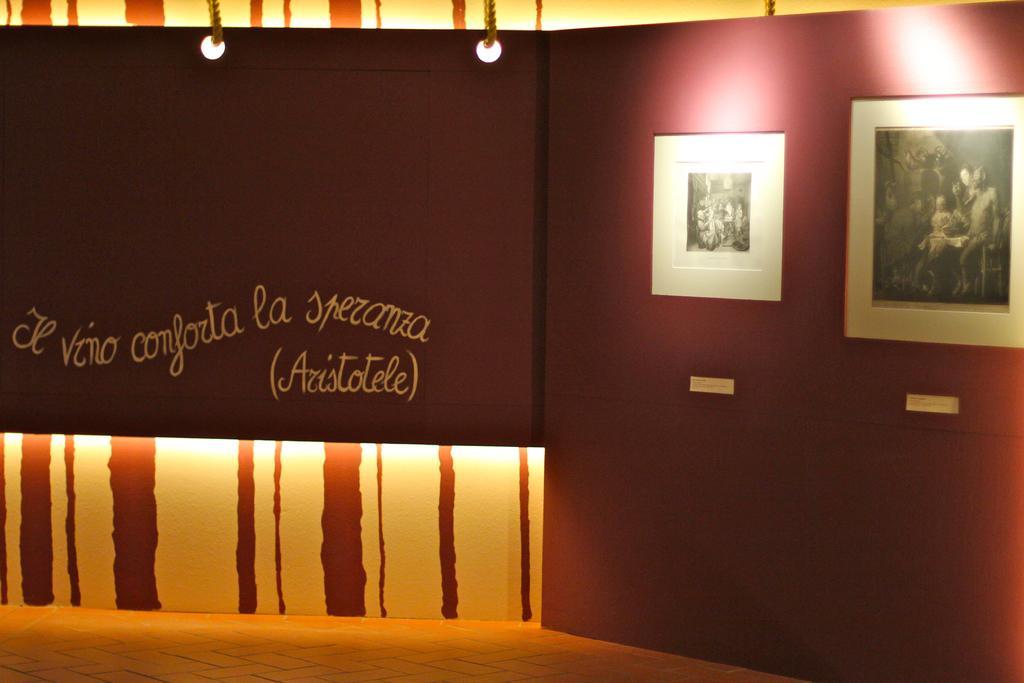How would you summarize this image in a sentence or two? In this image I can see the floor, the brown colored surface is tied with the ropes, two photo frame to the surface, and the wall which is cream and brown in color. I can see few lights. 